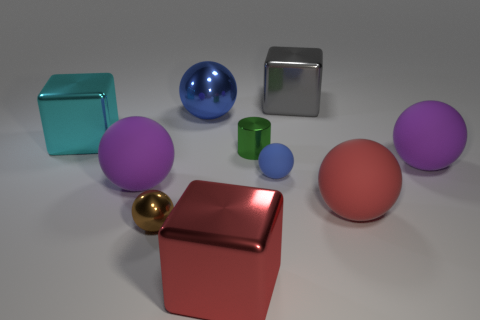What color is the sphere that is on the left side of the red ball and on the right side of the green shiny cylinder?
Give a very brief answer. Blue. Are there any metal things of the same color as the small metallic cylinder?
Your answer should be very brief. No. Is the material of the purple object that is to the right of the big gray cube the same as the purple object that is left of the gray shiny cube?
Your response must be concise. Yes. There is a ball that is behind the metallic cylinder; what is its size?
Keep it short and to the point. Large. The brown ball is what size?
Provide a succinct answer. Small. What size is the blue ball that is behind the large shiny cube that is to the left of the metallic sphere that is in front of the large cyan shiny cube?
Provide a succinct answer. Large. Are there any purple objects that have the same material as the cyan object?
Keep it short and to the point. No. What shape is the small blue thing?
Keep it short and to the point. Sphere. What is the color of the tiny sphere that is made of the same material as the large gray block?
Provide a succinct answer. Brown. What number of blue things are either metallic things or cylinders?
Your answer should be very brief. 1. 